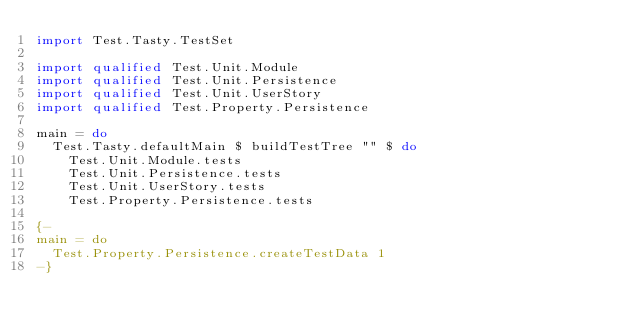Convert code to text. <code><loc_0><loc_0><loc_500><loc_500><_Haskell_>import Test.Tasty.TestSet

import qualified Test.Unit.Module
import qualified Test.Unit.Persistence
import qualified Test.Unit.UserStory
import qualified Test.Property.Persistence

main = do
  Test.Tasty.defaultMain $ buildTestTree "" $ do
    Test.Unit.Module.tests
    Test.Unit.Persistence.tests
    Test.Unit.UserStory.tests
    Test.Property.Persistence.tests

{-
main = do
  Test.Property.Persistence.createTestData 1
-}
</code> 